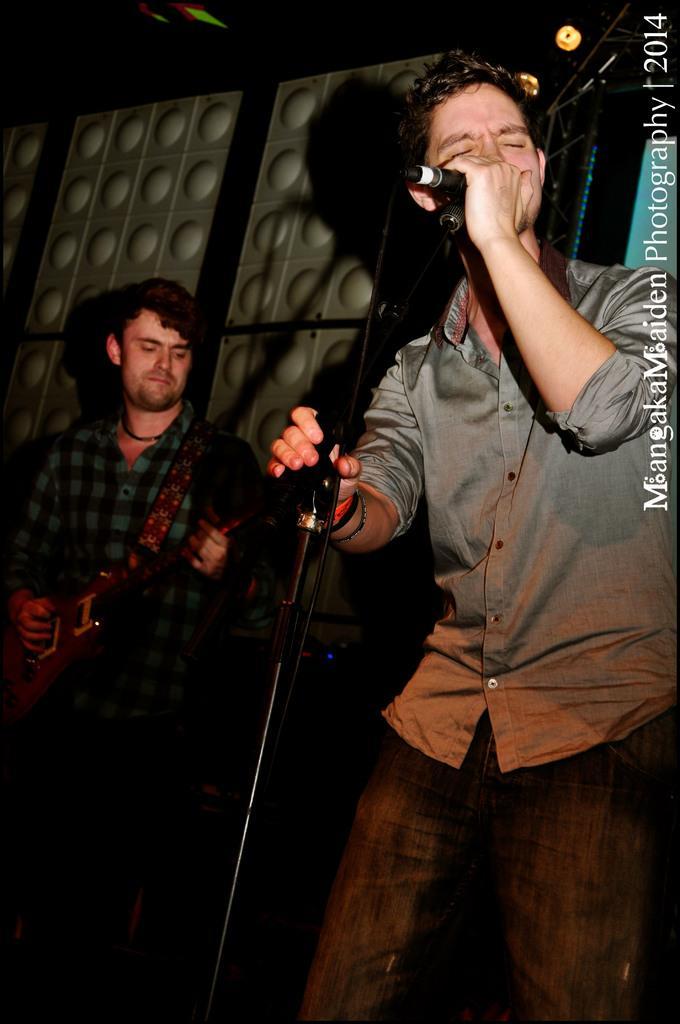Could you give a brief overview of what you see in this image? As we can see in the image there are two people. The man on the right side is holding mic and singing song and the man on left side is holding guitar. 